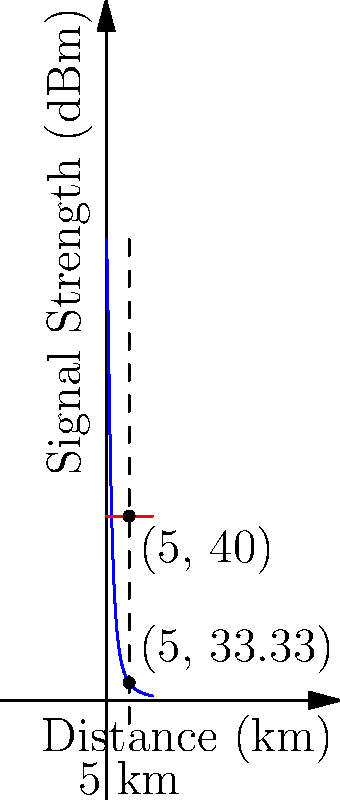Based on the diagram showing signal strength over distance, at what distance (in km) does the radio signal strength fall below the minimum required strength for effective communication? To solve this problem, we need to follow these steps:

1) The blue curve represents the signal strength as a function of distance, given by the equation:
   $$ S(x) = \frac{100}{1+x^2} $$
   where $S$ is the signal strength in dBm and $x$ is the distance in km.

2) The red line represents the minimum required signal strength, which is constant at 40 dBm.

3) We need to find the point where these two functions intersect. Mathematically, we need to solve:
   $$ \frac{100}{1+x^2} = 40 $$

4) Solving this equation:
   $$ 100 = 40(1+x^2) $$
   $$ 100 = 40 + 40x^2 $$
   $$ 60 = 40x^2 $$
   $$ \frac{3}{2} = x^2 $$
   $$ x = \sqrt{\frac{3}{2}} \approx 1.225 $$

5) Therefore, the signal strength falls below the minimum required strength at approximately 1.225 km.

6) However, as a field-experienced sergeant major, it's important to round this to a practical value. In real-world scenarios, we typically round to the nearest half kilometer for ease of communication and planning.
Answer: 1.5 km 